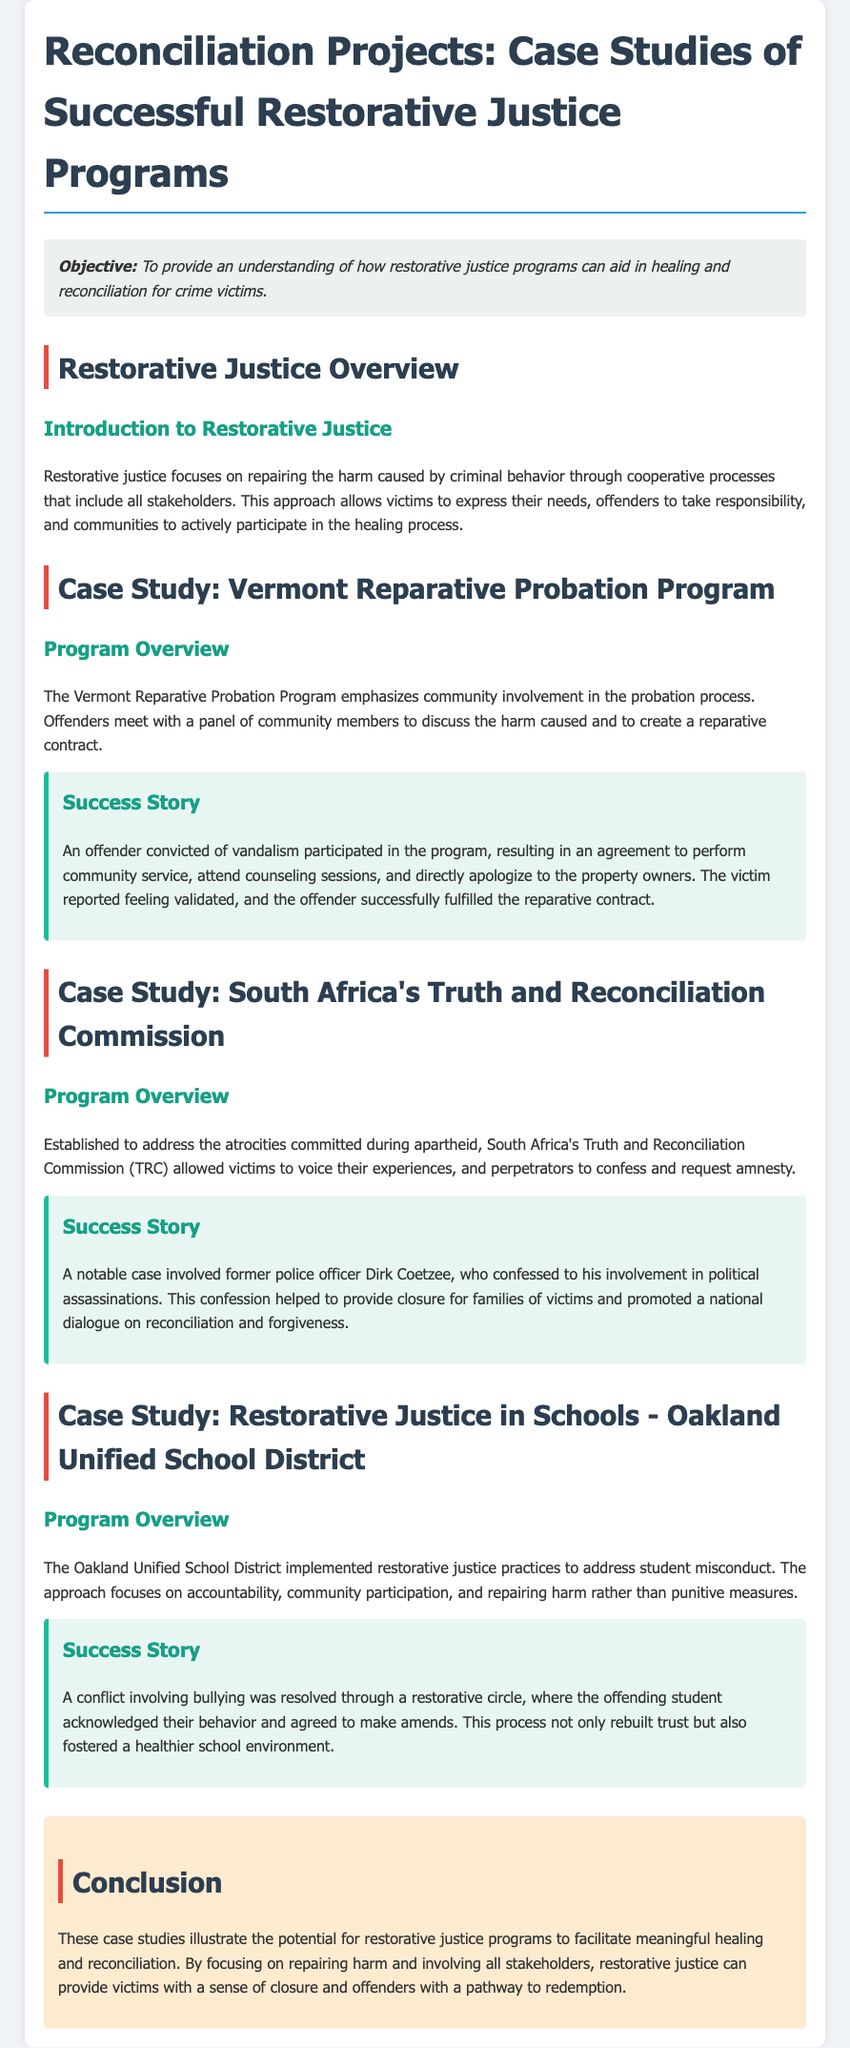what is the objective of the lesson plan? The objective aims to provide an understanding of restorative justice programs in relation to healing and reconciliation for crime victims.
Answer: To provide an understanding of how restorative justice programs can aid in healing and reconciliation for crime victims what program emphasizes community involvement in the probation process? The document mentions a specific program that emphasizes community participation in the probation process.
Answer: Vermont Reparative Probation Program who is a notable figure in the South Africa's Truth and Reconciliation Commission case study? The document provides the name of a former police officer involved in significant confessions during the TRC.
Answer: Dirk Coetzee what type of misconduct does the Oakland Unified School District's program address? The document discusses a particular issue that the Oakland Unified School District's program focuses on resolving among students.
Answer: Student misconduct what was the outcome for the victim in the Vermont Reparative Probation Program success story? The success story outlines how the victim felt after the reparative actions took place.
Answer: Validated how does restorative justice differ from punitive measures in schools? The document contrasts restorative justice practices with traditional disciplinary approaches regarding behavior correction.
Answer: Accountability and repairing harm what year was the South Africa's Truth and Reconciliation Commission established? The specific year of establishment for the TRC is not directly mentioned in the document but can be inferred from historical context; however, my focus is on the content of the document.
Answer: Not specified what main themes do the case studies illustrate? The conclusion emphasizes the overarching themes demonstrated across the various case studies presented in the document.
Answer: Healing and reconciliation 